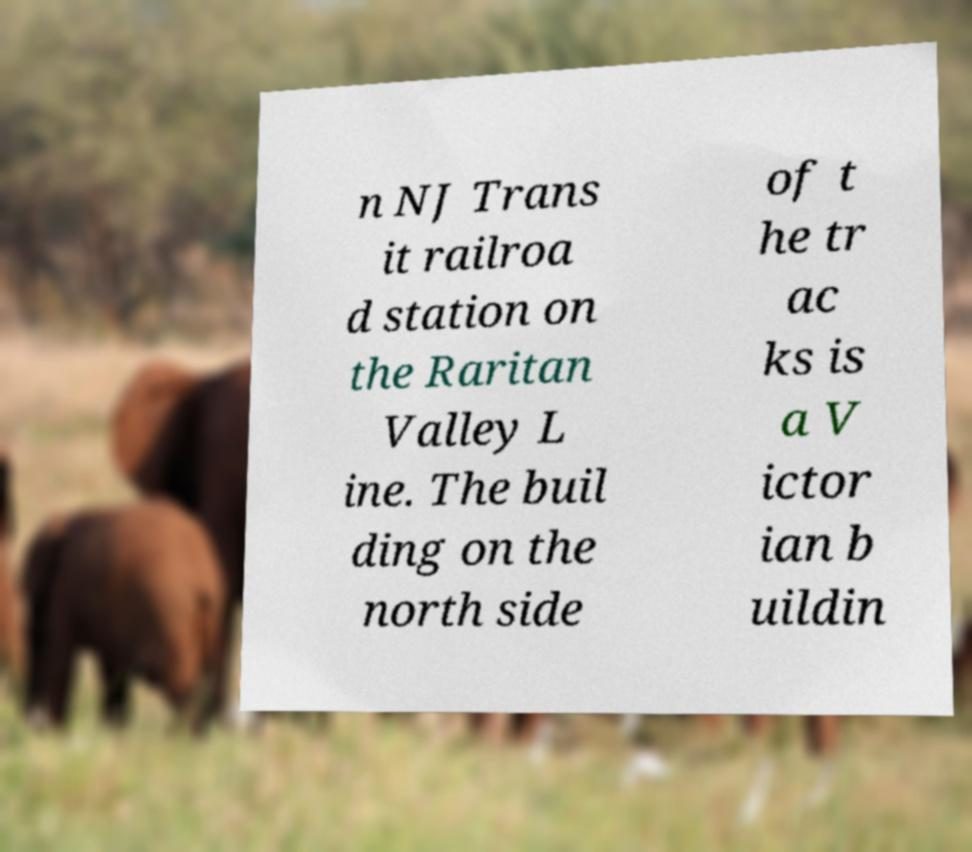Could you extract and type out the text from this image? n NJ Trans it railroa d station on the Raritan Valley L ine. The buil ding on the north side of t he tr ac ks is a V ictor ian b uildin 